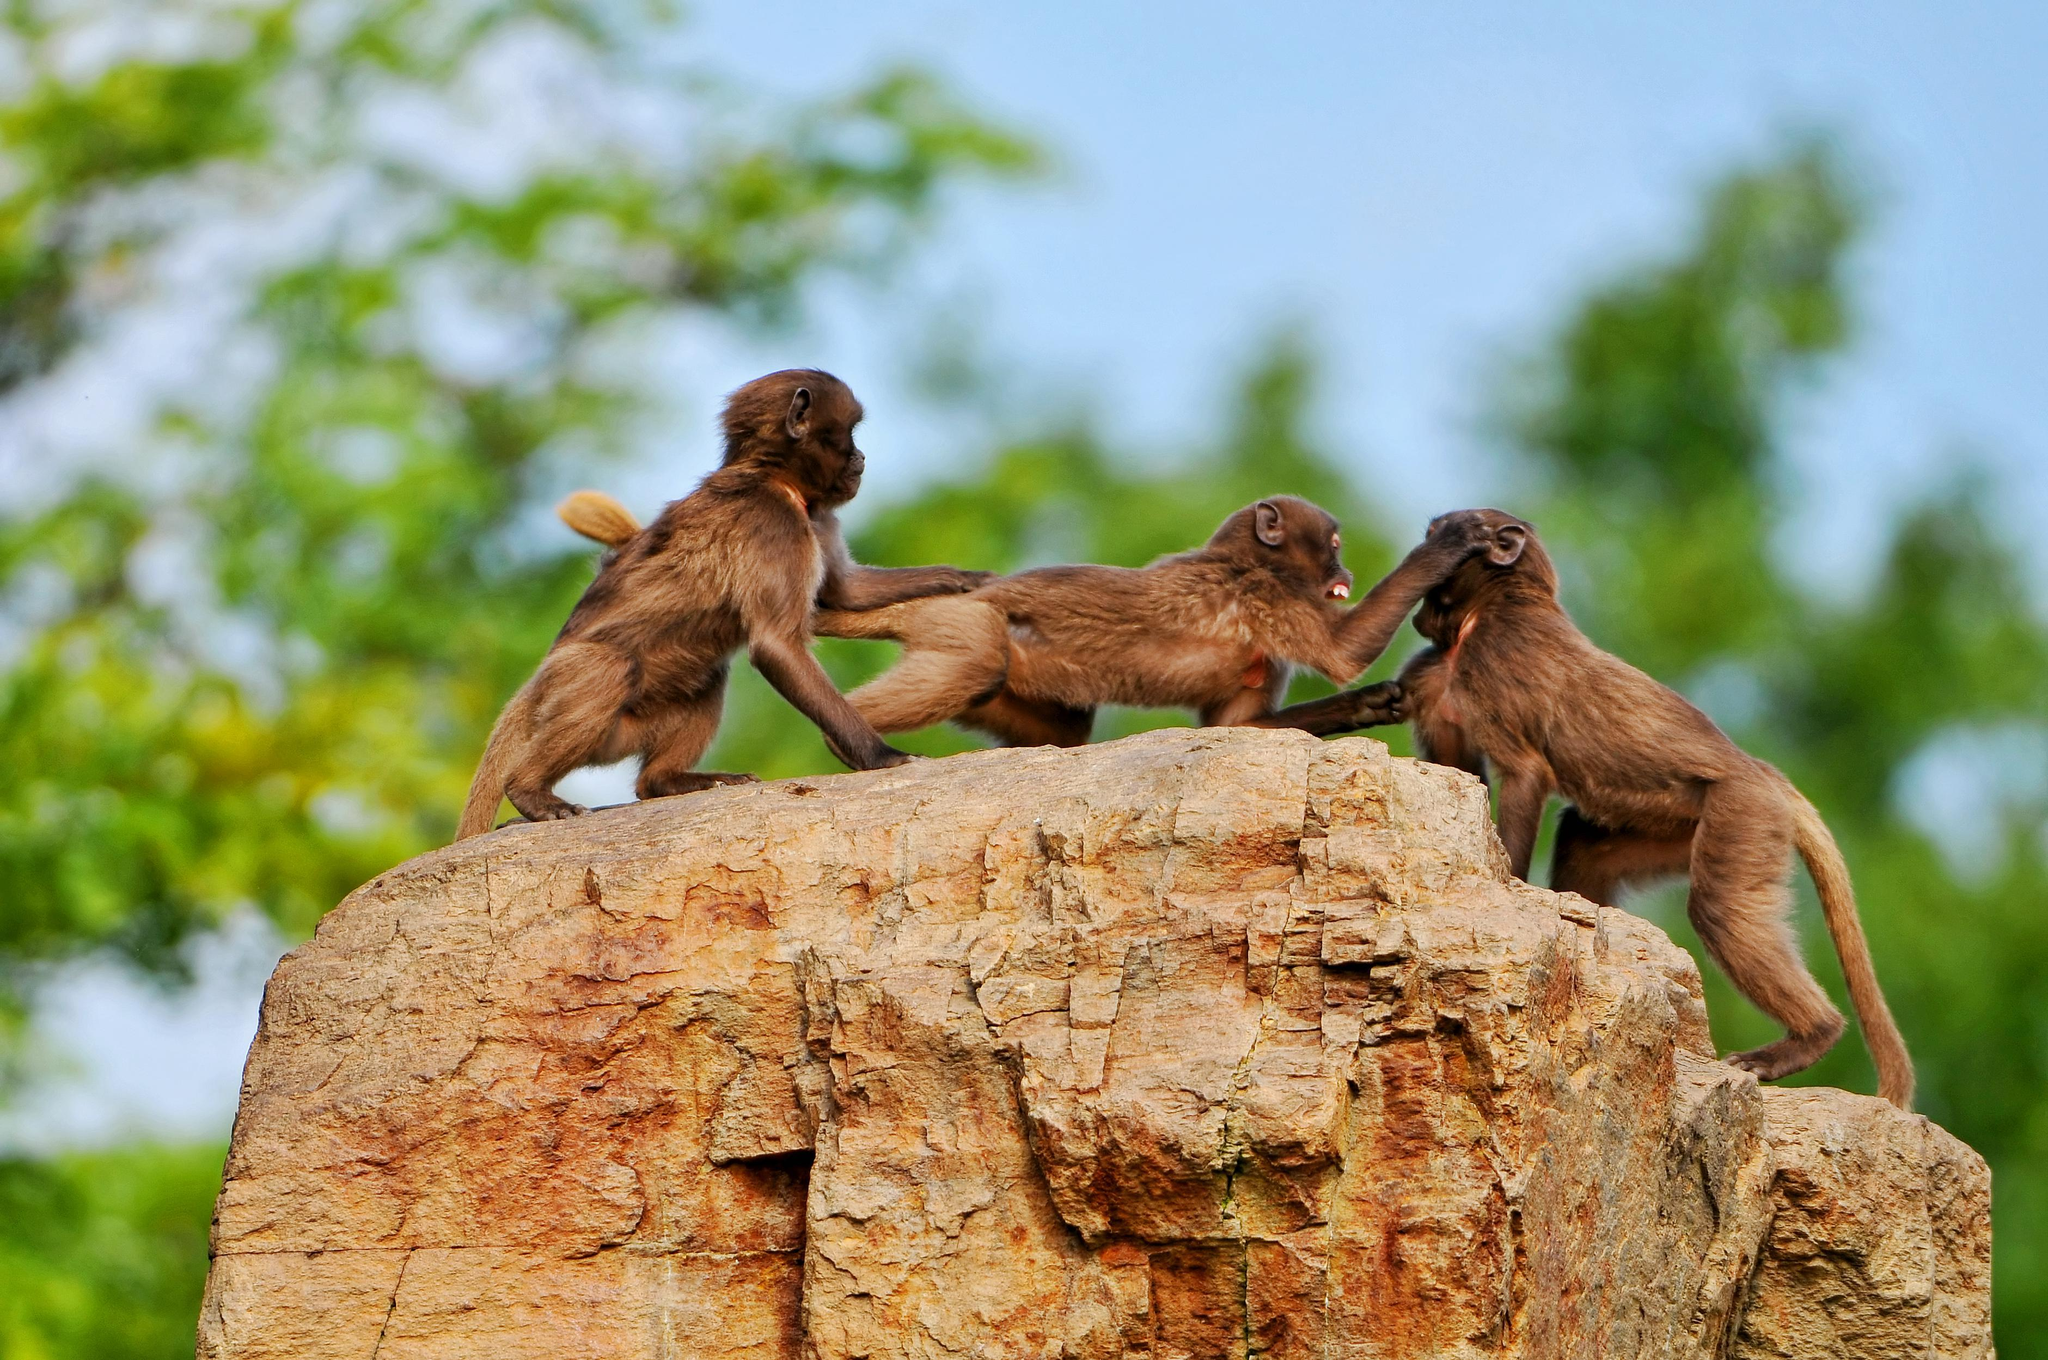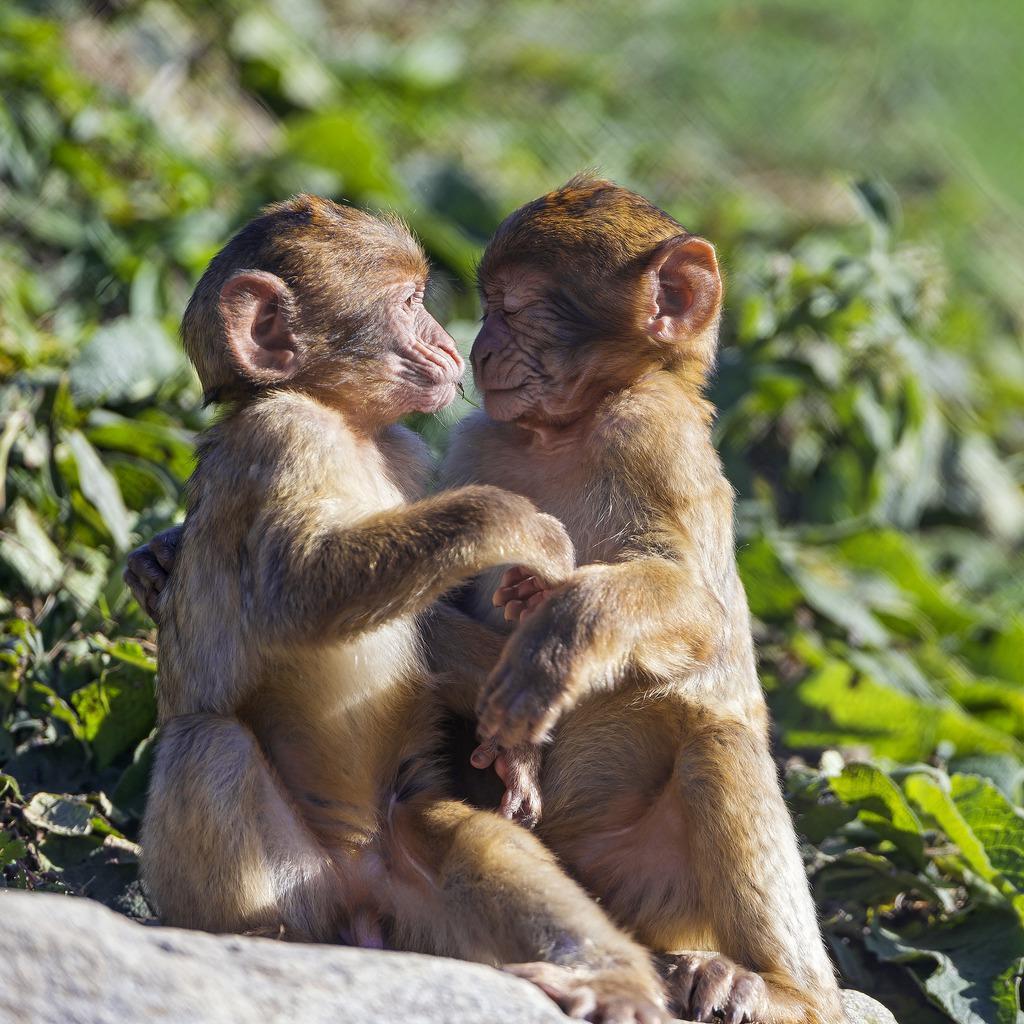The first image is the image on the left, the second image is the image on the right. Given the left and right images, does the statement "Three monkeys are in a row on a rock in one image." hold true? Answer yes or no. Yes. The first image is the image on the left, the second image is the image on the right. For the images shown, is this caption "There are more than three, but no more than five monkeys." true? Answer yes or no. Yes. 